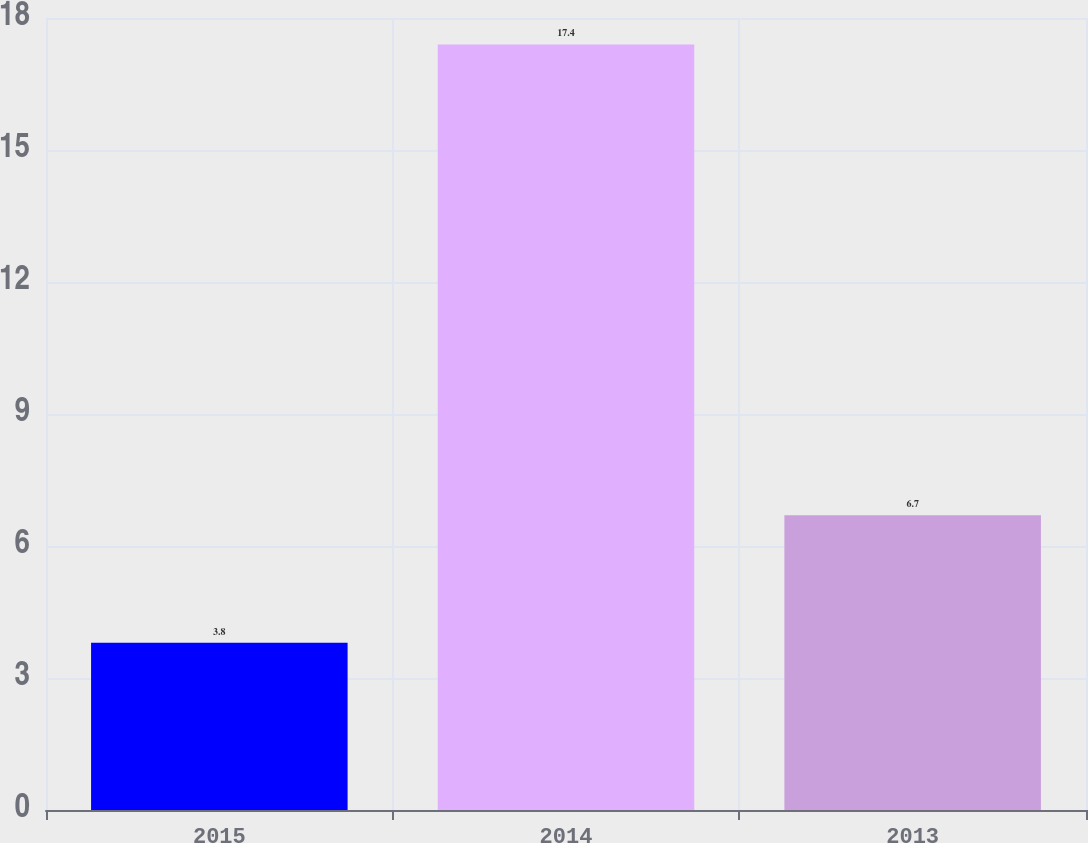Convert chart to OTSL. <chart><loc_0><loc_0><loc_500><loc_500><bar_chart><fcel>2015<fcel>2014<fcel>2013<nl><fcel>3.8<fcel>17.4<fcel>6.7<nl></chart> 